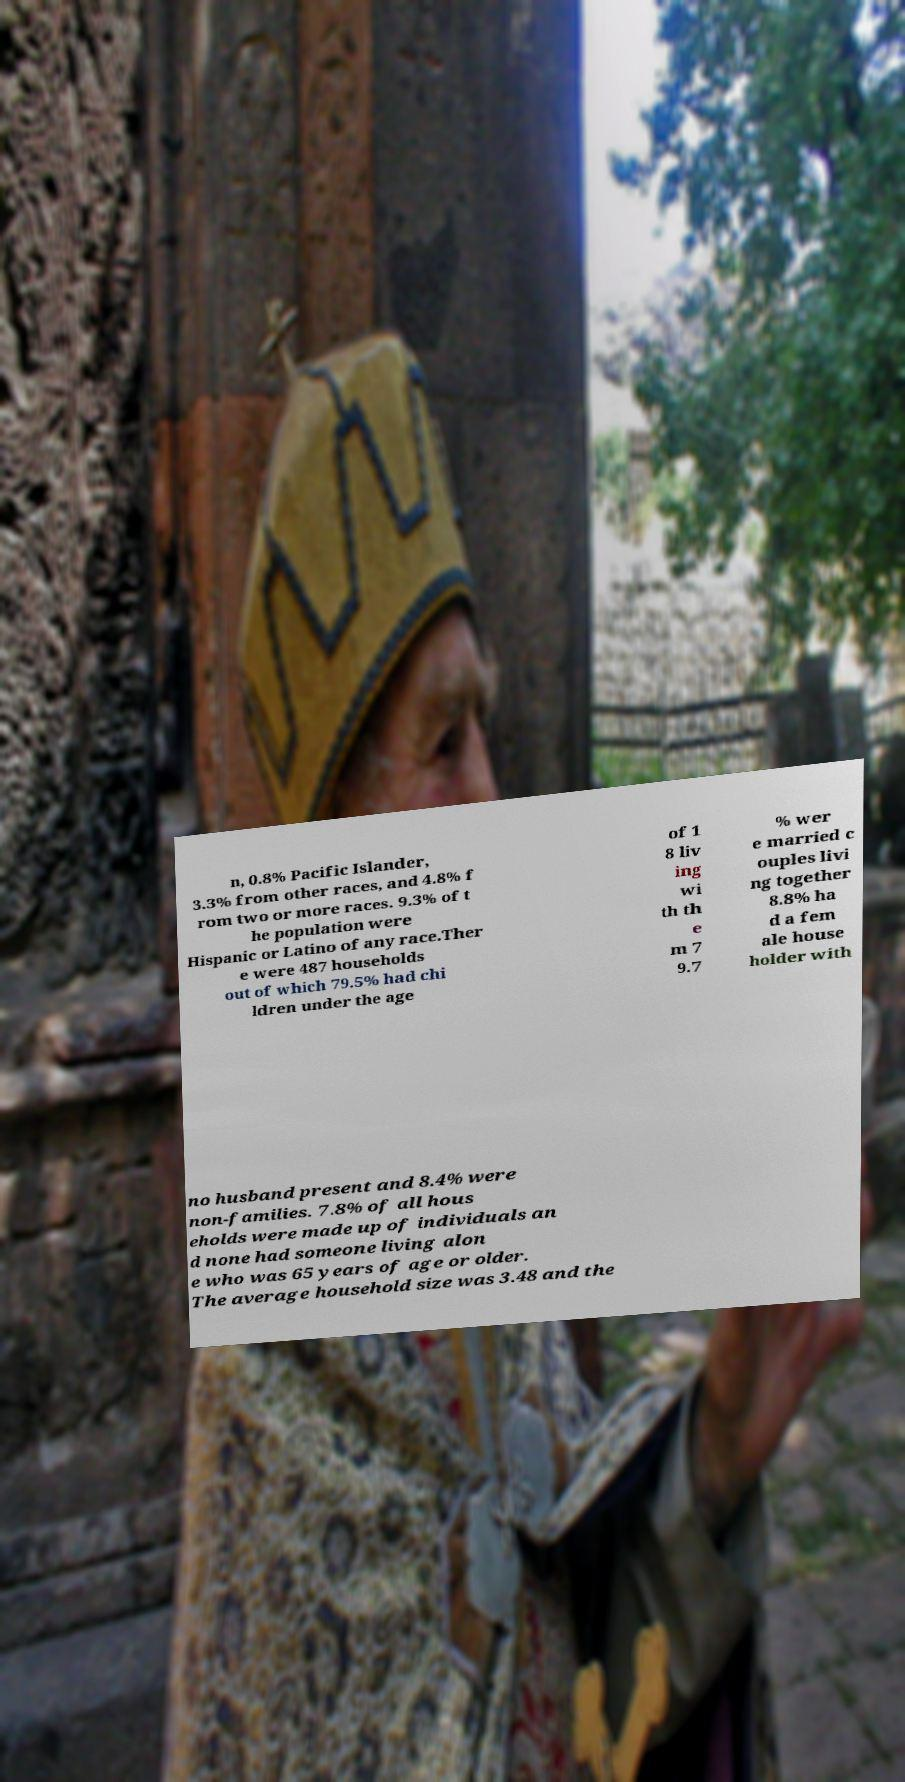Could you assist in decoding the text presented in this image and type it out clearly? n, 0.8% Pacific Islander, 3.3% from other races, and 4.8% f rom two or more races. 9.3% of t he population were Hispanic or Latino of any race.Ther e were 487 households out of which 79.5% had chi ldren under the age of 1 8 liv ing wi th th e m 7 9.7 % wer e married c ouples livi ng together 8.8% ha d a fem ale house holder with no husband present and 8.4% were non-families. 7.8% of all hous eholds were made up of individuals an d none had someone living alon e who was 65 years of age or older. The average household size was 3.48 and the 